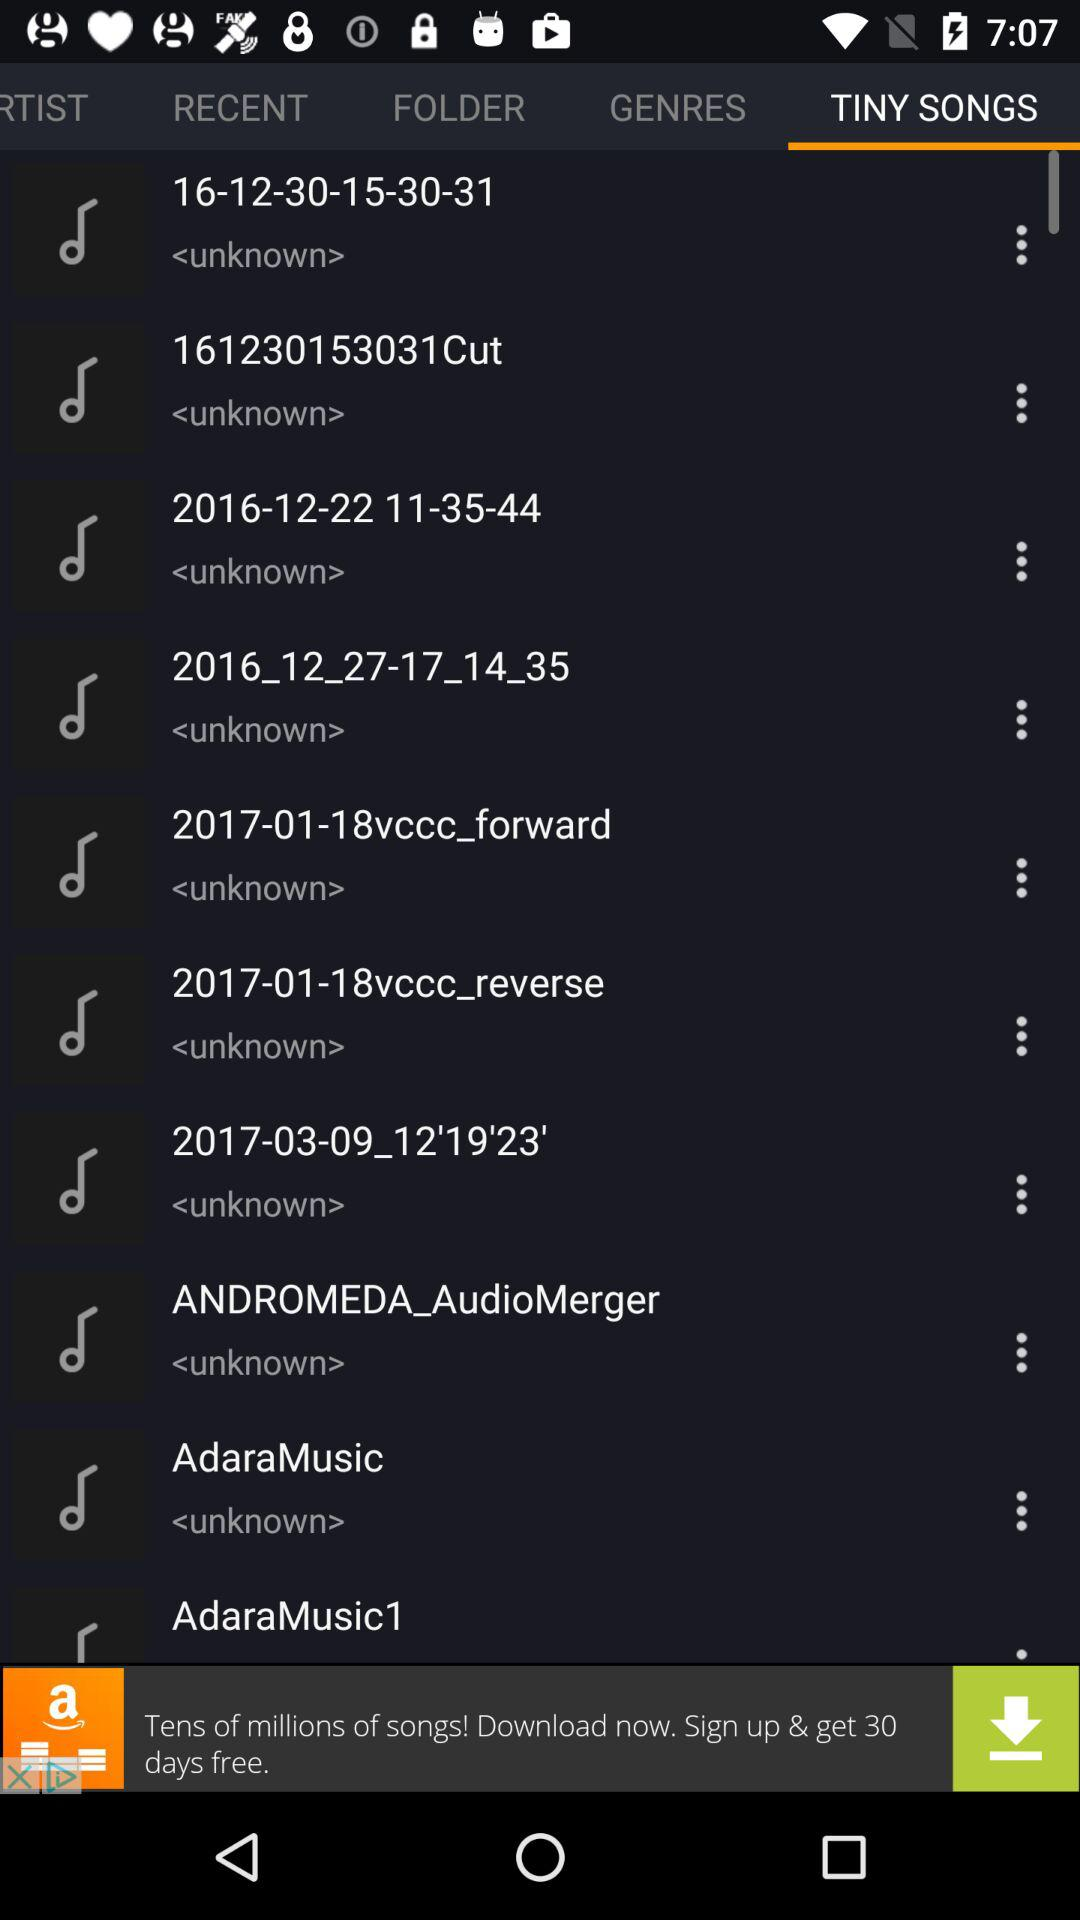What is the selected option? The selected option is "TINY SONGS". 